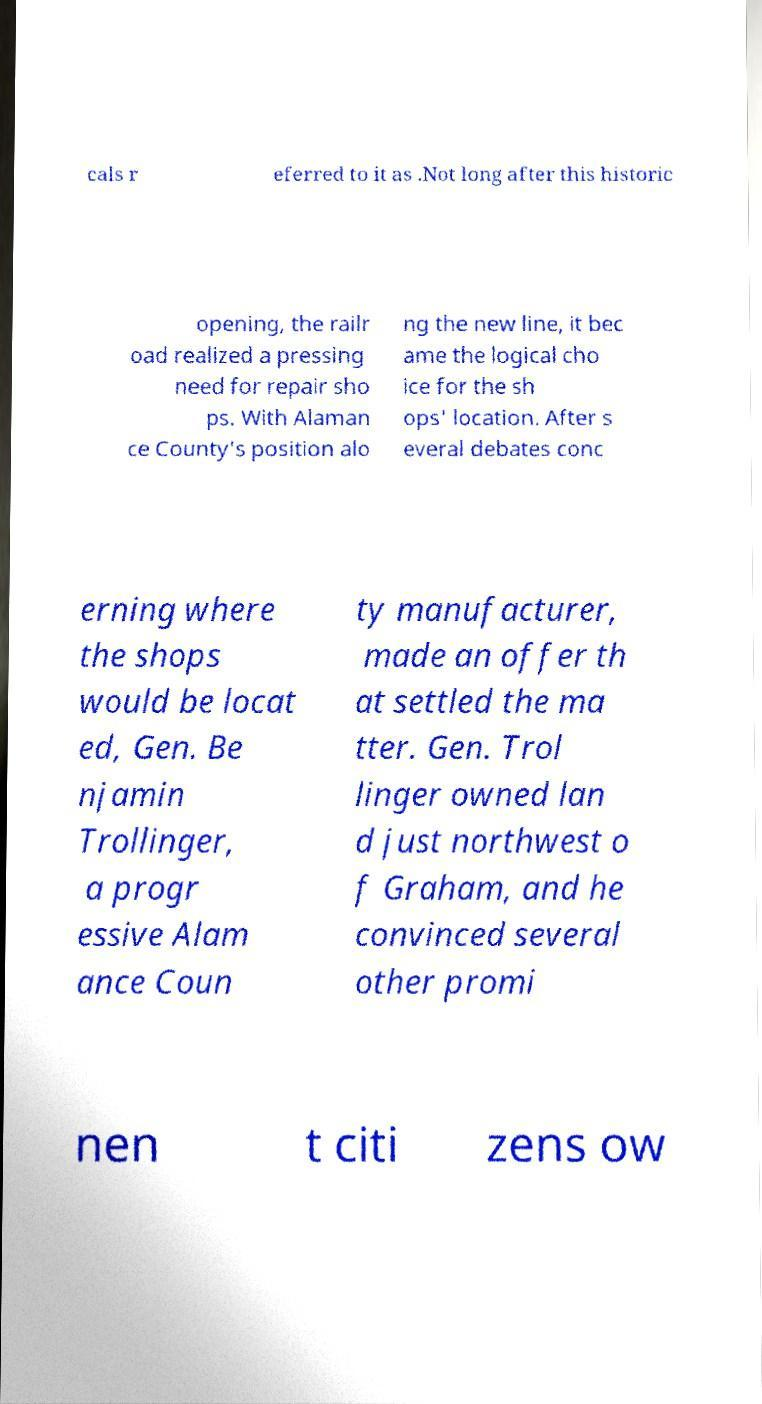Could you extract and type out the text from this image? cals r eferred to it as .Not long after this historic opening, the railr oad realized a pressing need for repair sho ps. With Alaman ce County's position alo ng the new line, it bec ame the logical cho ice for the sh ops' location. After s everal debates conc erning where the shops would be locat ed, Gen. Be njamin Trollinger, a progr essive Alam ance Coun ty manufacturer, made an offer th at settled the ma tter. Gen. Trol linger owned lan d just northwest o f Graham, and he convinced several other promi nen t citi zens ow 